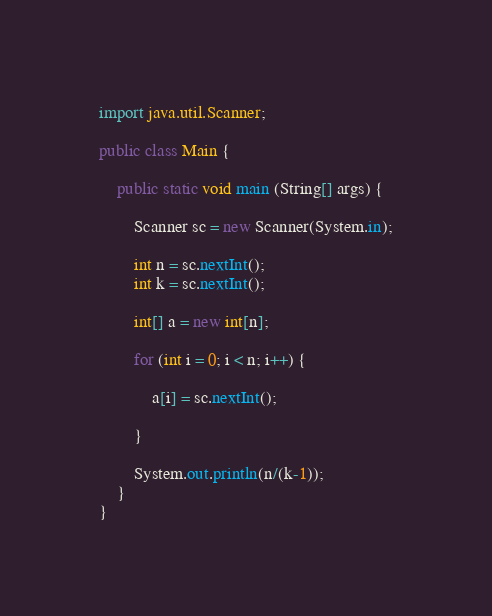<code> <loc_0><loc_0><loc_500><loc_500><_Java_>import java.util.Scanner;

public class Main {

	public static void main (String[] args) {

		Scanner sc = new Scanner(System.in);

		int n = sc.nextInt();
		int k = sc.nextInt();

		int[] a = new int[n];

		for (int i = 0; i < n; i++) {

			a[i] = sc.nextInt();

		}

		System.out.println(n/(k-1));
	}
}
</code> 